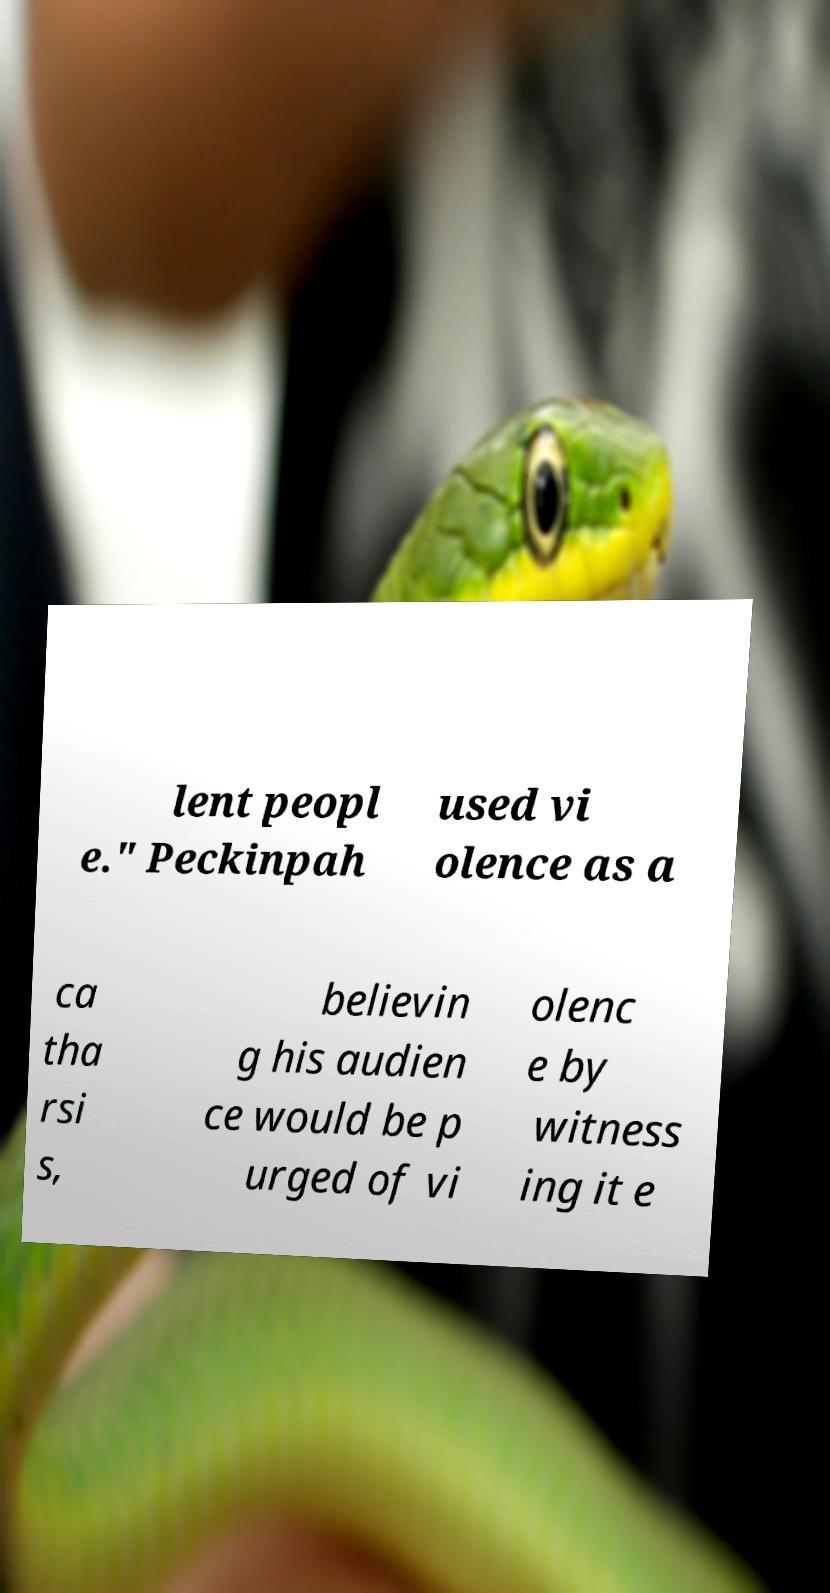Please identify and transcribe the text found in this image. lent peopl e." Peckinpah used vi olence as a ca tha rsi s, believin g his audien ce would be p urged of vi olenc e by witness ing it e 